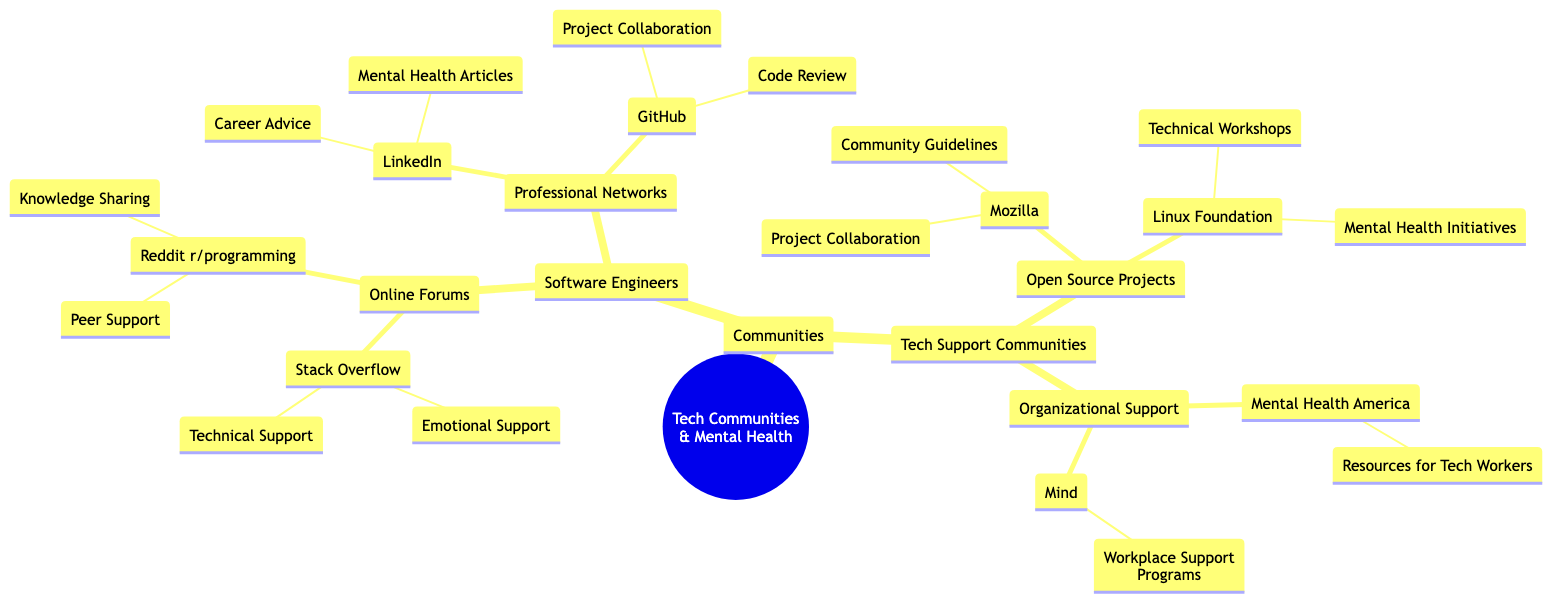What are the two main categories under "Communities"? The diagram shows "Software Engineers" and "Tech Support Communities" as the two primary branches under "Communities."
Answer: Software Engineers, Tech Support Communities How many online forums are listed under "Software Engineers"? There are two online forums mentioned, which are "Stack Overflow" and "Reddit r/programming."
Answer: 2 Which professional network provides "Career Advice"? The network that offers "Career Advice" is "LinkedIn."
Answer: LinkedIn What is one type of support listed under "Tech Support Communities"? The diagram specifies "Organizational Support" as one of the types present under "Tech Support Communities."
Answer: Organizational Support Which community has a mental health initiative? "Linux Foundation" is identified in the diagram as having "Mental Health Initiatives."
Answer: Linux Foundation How many different types of support are provided under "Open Source Projects"? The "Open Source Projects" category includes two types of support: "Mozilla" and "Linux Foundation," each with their respective offerings.
Answer: 2 What is the relationship between "Stack Overflow" and "Technical Support"? "Technical Support" is one of the children of "Stack Overflow," indicating it is a subcategory that falls under this forum.
Answer: Subcategory What kind of resources does "Mental Health America" offer? The diagram illustrates that "Mental Health America" provides "Resources for Tech Workers."
Answer: Resources for Tech Workers Which community is associated with project collaboration besides "GitHub"? In addition to "GitHub," "Mozilla" is also connected with "Project Collaboration."
Answer: Mozilla What type of support is provided by "Mind"? "Mind" offers "Workplace Support Programs," as indicated in the child node under "Organizational Support".
Answer: Workplace Support Programs 